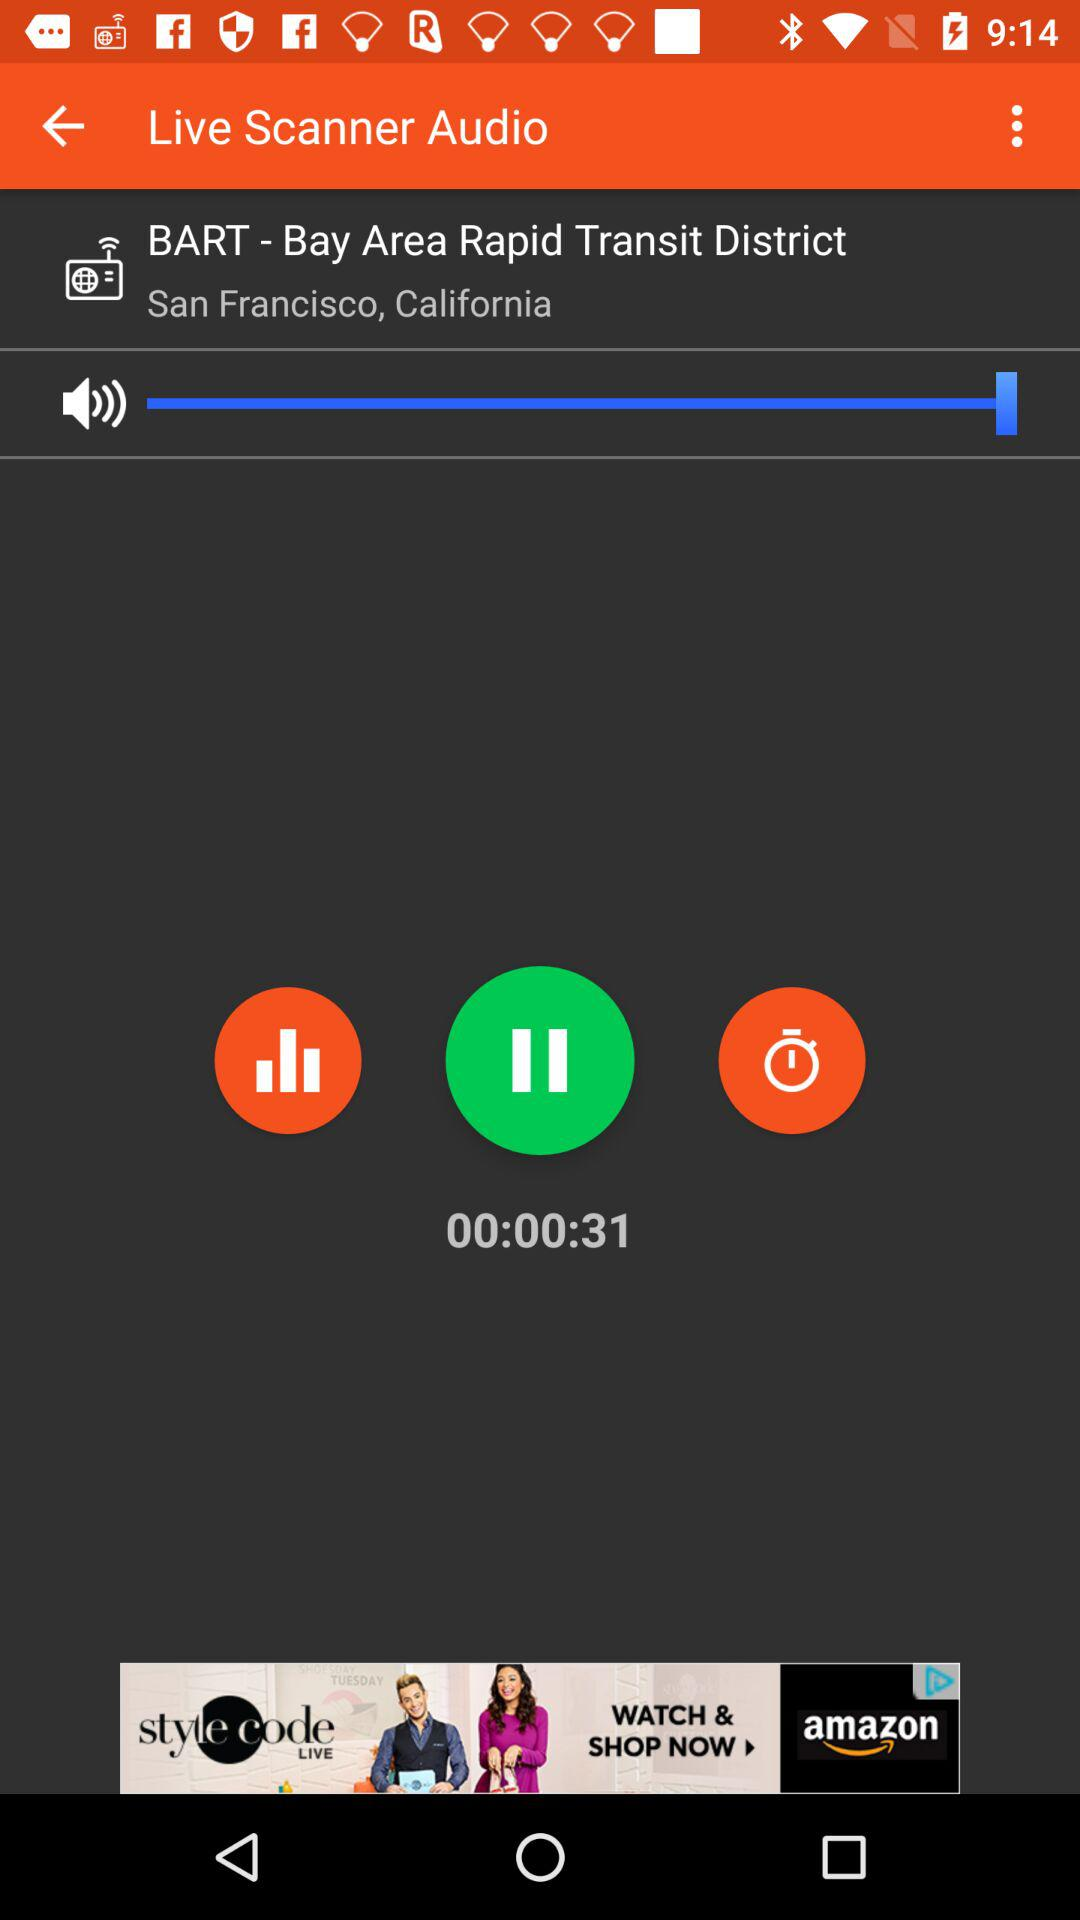What is the time duration of the audio? The time duration of the audio is 31 seconds. 